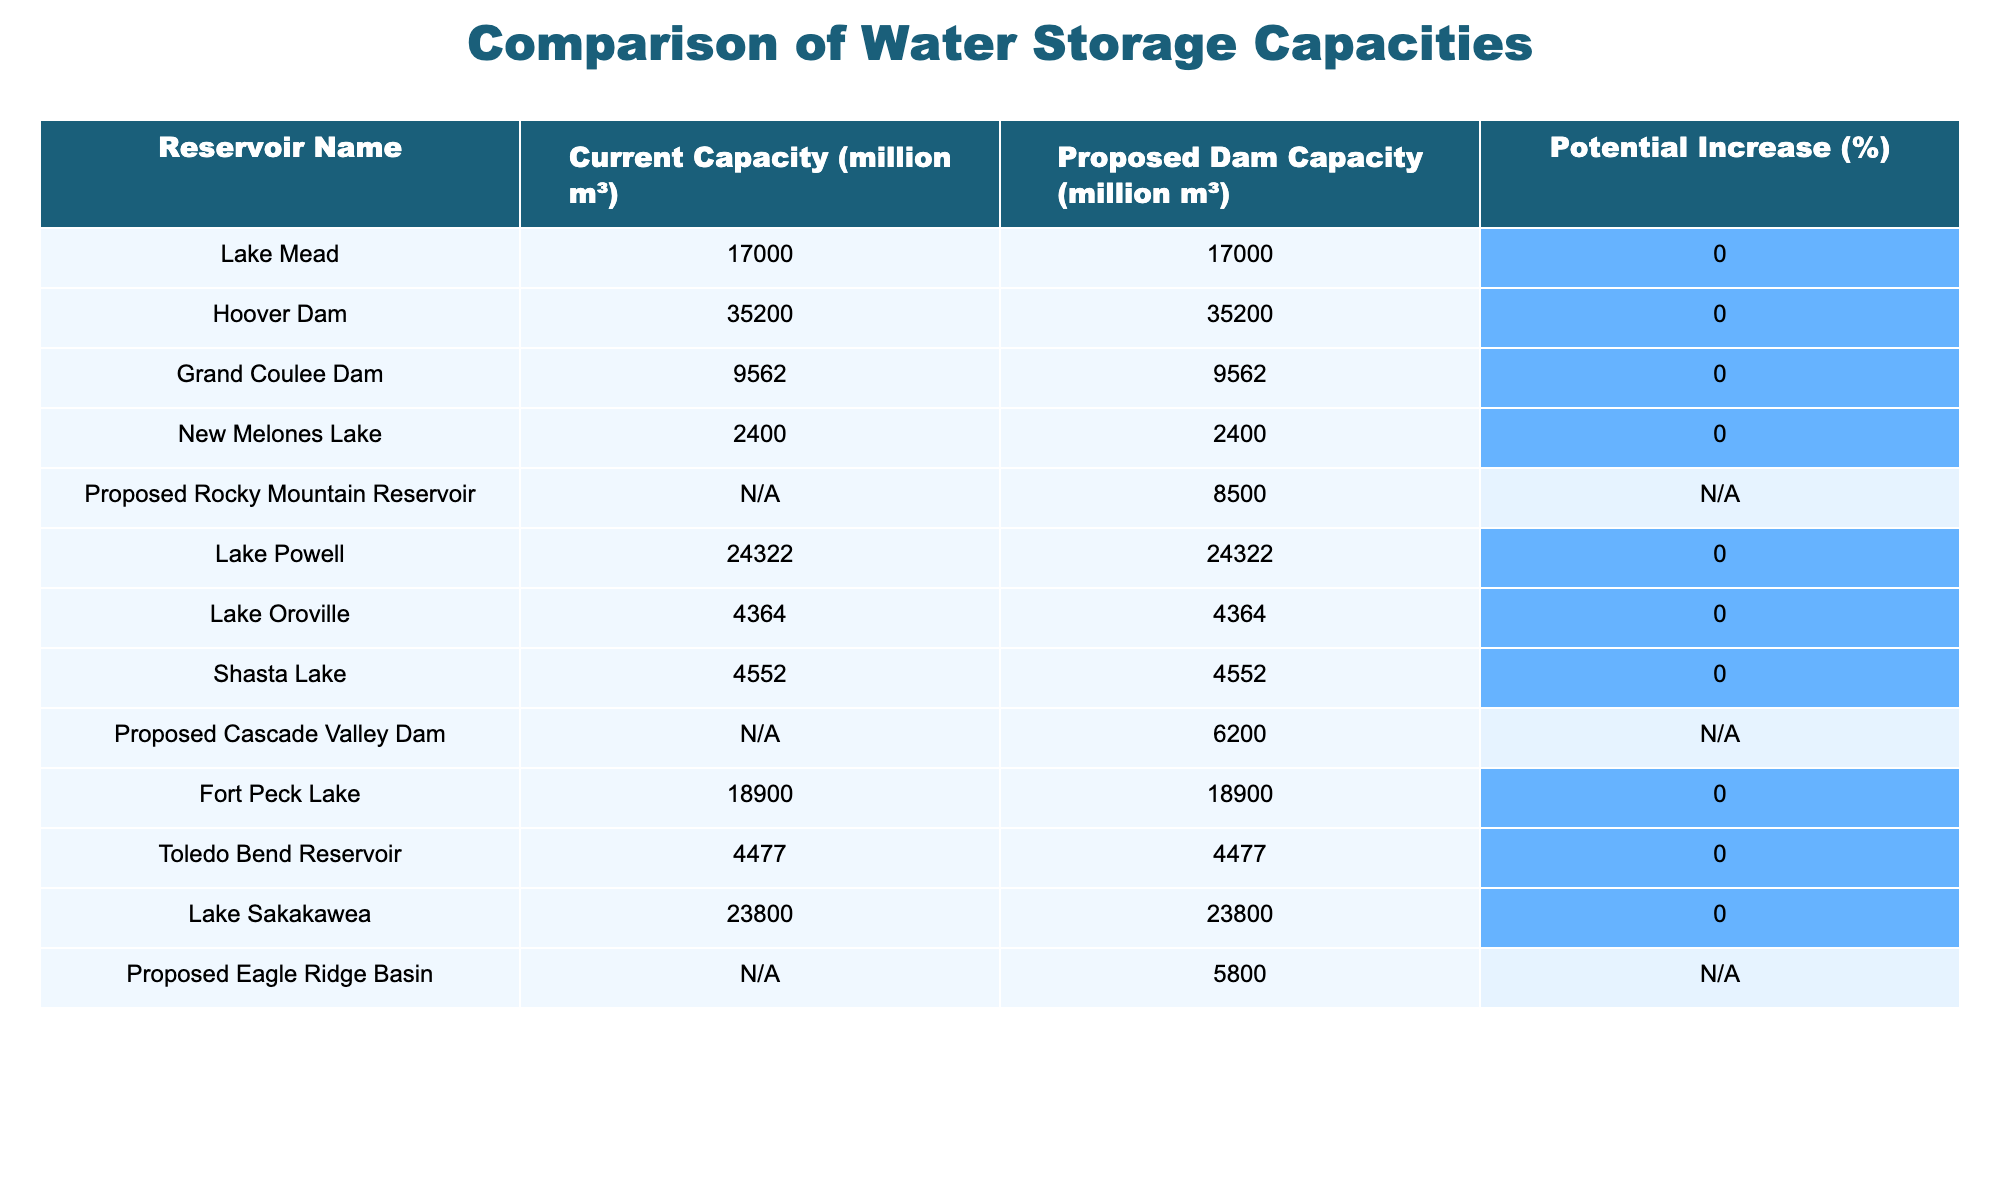What is the current capacity of Lake Powell? The table lists Lake Powell with a current capacity of 24,322 million m³.
Answer: 24,322 million m³ Is the proposed Rocky Mountain Reservoir's capacity greater than all existing reservoirs? The proposed Rocky Mountain Reservoir has a capacity of 8,500 million m³, which is lower than the current capacities of all existing reservoirs listed.
Answer: No How many existing reservoirs have a current capacity of more than 30,000 million m³? The table shows that Hoover Dam and Lake Powell are the only two existing reservoirs with a current capacity above 30,000 million m³.
Answer: 2 What is the total capacity of the proposed dams listed in the table? Adding the capacities of the proposed dams: 8,500 (Rocky Mountain) + 6,200 (Cascade Valley) + 5,800 (Eagle Ridge Basin) = 20,500 million m³.
Answer: 20,500 million m³ Which existing reservoir has the lowest current capacity? A quick review of the current capacities shows that New Melones Lake has the lowest capacity at 2,400 million m³.
Answer: 2,400 million m³ Is it true that all current reservoirs have a potential increase of 0%? The table indicates that all existing reservoirs have a potential increase percentage of 0%, confirming that there are no increases expected.
Answer: Yes What is the average current capacity of all existing reservoirs? To calculate the average, first sum the capacities of the existing reservoirs: (17,000 + 35,200 + 9,562 + 2,400 + 24,322 + 4,364 + 4,552 + 18,900 + 4,477 + 23,800) = 119,577 million m³. There are 10 existing reservoirs, so the average is 119,577 / 10 = 11,957.7 million m³.
Answer: 11,957.7 million m³ What percentage of the total current capacity of existing reservoirs does the proposed Cascade Valley Dam represent? The total capacity of existing reservoirs is 119,577 million m³, while the proposed Cascade Valley Dam has a capacity of 6,200 million m³. The calculation is (6,200 / 119,577) * 100 ≈ 5.18%.
Answer: Approximately 5.18% Are there any proposed dams with a capacity less than 5,000 million m³? The proposed Eagle Ridge Basin has a capacity of 5,800 million m³, while the others are approximately above this value. Thus, there are no proposed dams less than 5,000 million m³.
Answer: No 